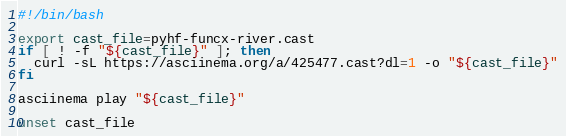<code> <loc_0><loc_0><loc_500><loc_500><_Bash_>#!/bin/bash

export cast_file=pyhf-funcx-river.cast
if [ ! -f "${cast_file}" ]; then
  curl -sL https://asciinema.org/a/425477.cast?dl=1 -o "${cast_file}"
fi

asciinema play "${cast_file}"

unset cast_file
</code> 